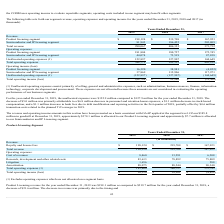According to Xperi Corporation's financial document, Why was Product Licensing revenue decreased in 2019 compared to 2018? Based on the financial document, the answer is the timing and duration of minimum guarantee contracts up for renewal and executed, decreased NRE services revenue, as well as a decrease in per-unit royalty revenue. Also, What was the total operating income/loss from 2017 to 2019, respectively? The document contains multiple relevant values: $(4,822), $38,981, $16,320 (in thousands). From the document: "Product licensing segment 16,320 38,981 (4,822) Product licensing segment 16,320 38,981 (4,822) Product licensing segment 16,320 38,981 (4,822)..." Also, What were the litigation costs in 2017 and 2019, respectively? The document shows two values: 288 and 1,656 (in thousands). From the document: "Litigation 1,656 — 288 Litigation 1,656 — 288..." Also, can you calculate: What is the overall proportion of litigation and amortization expense over the total operating expense in 2019? To answer this question, I need to perform calculations using the financial data. The calculation is: (1,656+88,075)/181,804 , which equals 0.49. This is based on the information: "Total operating expenses (1) 181,804 180,727 172,745 Amortization 88,075 88,544 90,340 Litigation 1,656 — 288..." The key data points involved are: 1,656, 181,804, 88,075. Also, can you calculate: What is the percentage change in total revenue in 2019 compared to 2018? To answer this question, I need to perform calculations using the financial data. The calculation is: (198,124-219,708)/219,708 , which equals -9.82 (percentage). This is based on the information: "Product licensing segment $ 198,124 $ 219,708 $ 167,923 Product licensing segment $ 198,124 $ 219,708 $ 167,923..." The key data points involved are: 198,124, 219,708. Also, can you calculate: What is the average total operating expense from 2017 to 2019? To answer this question, I need to perform calculations using the financial data. The calculation is: (172,745+180,727+181,804)/3 , which equals 178425.33 (in thousands). This is based on the information: "Total operating expenses (1) 181,804 180,727 172,745 Total operating expenses (1) 181,804 180,727 172,745 Total operating expenses (1) 181,804 180,727 172,745..." The key data points involved are: 172,745, 180,727, 181,804. 